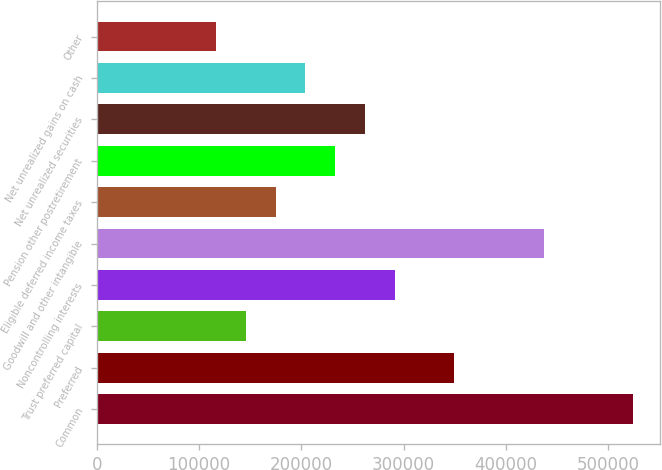Convert chart to OTSL. <chart><loc_0><loc_0><loc_500><loc_500><bar_chart><fcel>Common<fcel>Preferred<fcel>Trust preferred capital<fcel>Noncontrolling interests<fcel>Goodwill and other intangible<fcel>Eligible deferred income taxes<fcel>Pension other postretirement<fcel>Net unrealized securities<fcel>Net unrealized gains on cash<fcel>Other<nl><fcel>524559<fcel>349709<fcel>145718<fcel>291426<fcel>437134<fcel>174859<fcel>233143<fcel>262284<fcel>204001<fcel>116576<nl></chart> 